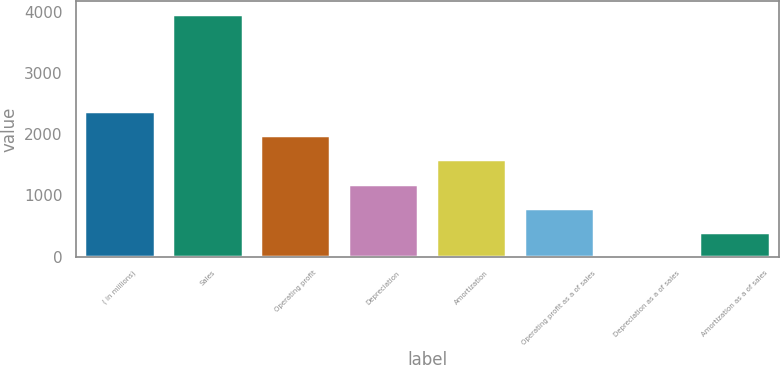<chart> <loc_0><loc_0><loc_500><loc_500><bar_chart><fcel>( in millions)<fcel>Sales<fcel>Operating profit<fcel>Depreciation<fcel>Amortization<fcel>Operating profit as a of sales<fcel>Depreciation as a of sales<fcel>Amortization as a of sales<nl><fcel>2381.72<fcel>3968.8<fcel>1984.95<fcel>1191.41<fcel>1588.18<fcel>794.64<fcel>1.1<fcel>397.87<nl></chart> 